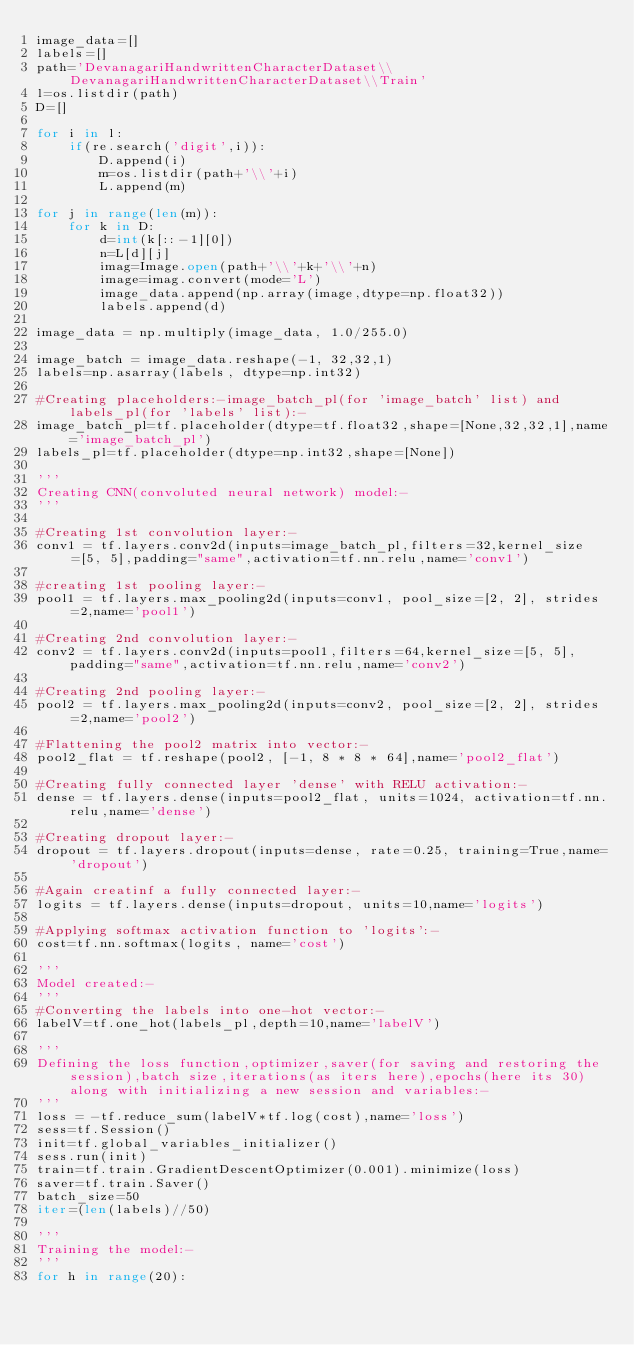Convert code to text. <code><loc_0><loc_0><loc_500><loc_500><_Python_>image_data=[]
labels=[]
path='DevanagariHandwrittenCharacterDataset\\DevanagariHandwrittenCharacterDataset\\Train'
l=os.listdir(path)
D=[]

for i in l:
    if(re.search('digit',i)):
        D.append(i)
        m=os.listdir(path+'\\'+i)
        L.append(m)

for j in range(len(m)):
    for k in D:
        d=int(k[::-1][0])
        n=L[d][j]
        imag=Image.open(path+'\\'+k+'\\'+n)
        image=imag.convert(mode='L')
        image_data.append(np.array(image,dtype=np.float32))
        labels.append(d)

image_data = np.multiply(image_data, 1.0/255.0)

image_batch = image_data.reshape(-1, 32,32,1)
labels=np.asarray(labels, dtype=np.int32)			

#Creating placeholders:-image_batch_pl(for 'image_batch' list) and labels_pl(for 'labels' list):- 
image_batch_pl=tf.placeholder(dtype=tf.float32,shape=[None,32,32,1],name='image_batch_pl')
labels_pl=tf.placeholder(dtype=np.int32,shape=[None])

'''
Creating CNN(convoluted neural network) model:-
'''

#Creating 1st convolution layer:-
conv1 = tf.layers.conv2d(inputs=image_batch_pl,filters=32,kernel_size=[5, 5],padding="same",activation=tf.nn.relu,name='conv1')

#creating 1st pooling layer:-
pool1 = tf.layers.max_pooling2d(inputs=conv1, pool_size=[2, 2], strides=2,name='pool1')

#Creating 2nd convolution layer:-
conv2 = tf.layers.conv2d(inputs=pool1,filters=64,kernel_size=[5, 5],padding="same",activation=tf.nn.relu,name='conv2')
 
#Creating 2nd pooling layer:- 
pool2 = tf.layers.max_pooling2d(inputs=conv2, pool_size=[2, 2], strides=2,name='pool2')

#Flattening the pool2 matrix into vector:-
pool2_flat = tf.reshape(pool2, [-1, 8 * 8 * 64],name='pool2_flat')

#Creating fully connected layer 'dense' with RELU activation:-
dense = tf.layers.dense(inputs=pool2_flat, units=1024, activation=tf.nn.relu,name='dense')

#Creating dropout layer:-
dropout = tf.layers.dropout(inputs=dense, rate=0.25, training=True,name='dropout')

#Again creatinf a fully connected layer:-
logits = tf.layers.dense(inputs=dropout, units=10,name='logits')

#Applying softmax activation function to 'logits':-
cost=tf.nn.softmax(logits, name='cost')

'''
Model created:-
'''
#Converting the labels into one-hot vector:-
labelV=tf.one_hot(labels_pl,depth=10,name='labelV')

'''
Defining the loss function,optimizer,saver(for saving and restoring the session),batch size,iterations(as iters here),epochs(here its 30) along with initializing a new session and variables:-
'''
loss = -tf.reduce_sum(labelV*tf.log(cost),name='loss')
sess=tf.Session()
init=tf.global_variables_initializer()
sess.run(init)
train=tf.train.GradientDescentOptimizer(0.001).minimize(loss)
saver=tf.train.Saver()
batch_size=50
iter=(len(labels)//50)

'''
Training the model:-
'''
for h in range(20):</code> 